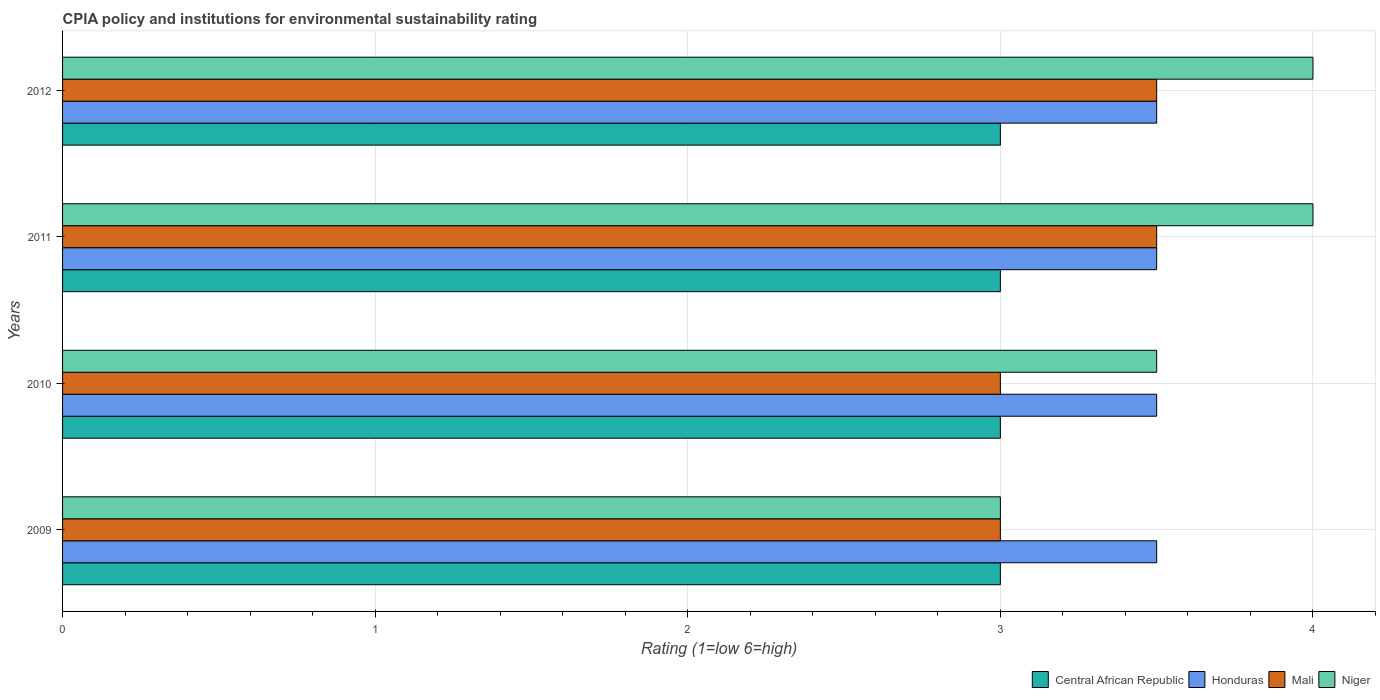How many groups of bars are there?
Make the answer very short. 4. How many bars are there on the 2nd tick from the bottom?
Offer a very short reply. 4. In how many cases, is the number of bars for a given year not equal to the number of legend labels?
Your answer should be compact. 0. What is the CPIA rating in Honduras in 2010?
Offer a very short reply. 3.5. Across all years, what is the maximum CPIA rating in Mali?
Keep it short and to the point. 3.5. Across all years, what is the minimum CPIA rating in Mali?
Your answer should be very brief. 3. In which year was the CPIA rating in Niger maximum?
Your answer should be compact. 2011. What is the difference between the CPIA rating in Central African Republic in 2009 and the CPIA rating in Mali in 2011?
Give a very brief answer. -0.5. What is the average CPIA rating in Honduras per year?
Offer a very short reply. 3.5. In how many years, is the CPIA rating in Niger greater than 0.4 ?
Keep it short and to the point. 4. What is the ratio of the CPIA rating in Honduras in 2009 to that in 2010?
Ensure brevity in your answer.  1. What is the difference between the highest and the second highest CPIA rating in Niger?
Your answer should be very brief. 0. What is the difference between the highest and the lowest CPIA rating in Niger?
Provide a succinct answer. 1. Is it the case that in every year, the sum of the CPIA rating in Central African Republic and CPIA rating in Mali is greater than the sum of CPIA rating in Honduras and CPIA rating in Niger?
Offer a very short reply. No. What does the 4th bar from the top in 2011 represents?
Your answer should be very brief. Central African Republic. What does the 4th bar from the bottom in 2010 represents?
Provide a succinct answer. Niger. Is it the case that in every year, the sum of the CPIA rating in Mali and CPIA rating in Niger is greater than the CPIA rating in Honduras?
Provide a short and direct response. Yes. Are all the bars in the graph horizontal?
Your answer should be compact. Yes. How many years are there in the graph?
Your answer should be very brief. 4. What is the difference between two consecutive major ticks on the X-axis?
Make the answer very short. 1. Does the graph contain any zero values?
Offer a very short reply. No. Does the graph contain grids?
Make the answer very short. Yes. How many legend labels are there?
Offer a terse response. 4. What is the title of the graph?
Offer a very short reply. CPIA policy and institutions for environmental sustainability rating. Does "Guatemala" appear as one of the legend labels in the graph?
Your answer should be compact. No. What is the label or title of the X-axis?
Ensure brevity in your answer.  Rating (1=low 6=high). What is the Rating (1=low 6=high) of Central African Republic in 2009?
Give a very brief answer. 3. What is the Rating (1=low 6=high) in Honduras in 2009?
Your response must be concise. 3.5. What is the Rating (1=low 6=high) in Mali in 2009?
Give a very brief answer. 3. What is the Rating (1=low 6=high) in Niger in 2009?
Provide a short and direct response. 3. What is the Rating (1=low 6=high) in Central African Republic in 2010?
Make the answer very short. 3. What is the Rating (1=low 6=high) of Honduras in 2010?
Give a very brief answer. 3.5. What is the Rating (1=low 6=high) in Mali in 2010?
Offer a terse response. 3. What is the Rating (1=low 6=high) in Niger in 2010?
Give a very brief answer. 3.5. What is the Rating (1=low 6=high) of Central African Republic in 2011?
Offer a very short reply. 3. What is the Rating (1=low 6=high) of Honduras in 2011?
Your answer should be compact. 3.5. What is the Rating (1=low 6=high) in Mali in 2011?
Keep it short and to the point. 3.5. What is the Rating (1=low 6=high) of Niger in 2011?
Provide a succinct answer. 4. What is the Rating (1=low 6=high) in Central African Republic in 2012?
Your answer should be compact. 3. What is the Rating (1=low 6=high) in Mali in 2012?
Give a very brief answer. 3.5. What is the Rating (1=low 6=high) in Niger in 2012?
Offer a very short reply. 4. Across all years, what is the maximum Rating (1=low 6=high) in Central African Republic?
Your response must be concise. 3. Across all years, what is the maximum Rating (1=low 6=high) of Niger?
Ensure brevity in your answer.  4. Across all years, what is the minimum Rating (1=low 6=high) of Mali?
Offer a very short reply. 3. What is the total Rating (1=low 6=high) in Central African Republic in the graph?
Keep it short and to the point. 12. What is the total Rating (1=low 6=high) in Mali in the graph?
Give a very brief answer. 13. What is the total Rating (1=low 6=high) of Niger in the graph?
Make the answer very short. 14.5. What is the difference between the Rating (1=low 6=high) in Honduras in 2009 and that in 2011?
Ensure brevity in your answer.  0. What is the difference between the Rating (1=low 6=high) in Mali in 2009 and that in 2011?
Offer a terse response. -0.5. What is the difference between the Rating (1=low 6=high) in Niger in 2009 and that in 2011?
Offer a very short reply. -1. What is the difference between the Rating (1=low 6=high) of Honduras in 2009 and that in 2012?
Ensure brevity in your answer.  0. What is the difference between the Rating (1=low 6=high) in Mali in 2009 and that in 2012?
Your answer should be very brief. -0.5. What is the difference between the Rating (1=low 6=high) of Central African Republic in 2010 and that in 2011?
Ensure brevity in your answer.  0. What is the difference between the Rating (1=low 6=high) of Niger in 2010 and that in 2011?
Provide a short and direct response. -0.5. What is the difference between the Rating (1=low 6=high) of Central African Republic in 2010 and that in 2012?
Ensure brevity in your answer.  0. What is the difference between the Rating (1=low 6=high) of Mali in 2010 and that in 2012?
Your response must be concise. -0.5. What is the difference between the Rating (1=low 6=high) in Niger in 2010 and that in 2012?
Your answer should be very brief. -0.5. What is the difference between the Rating (1=low 6=high) in Central African Republic in 2009 and the Rating (1=low 6=high) in Mali in 2010?
Provide a succinct answer. 0. What is the difference between the Rating (1=low 6=high) in Central African Republic in 2009 and the Rating (1=low 6=high) in Niger in 2010?
Ensure brevity in your answer.  -0.5. What is the difference between the Rating (1=low 6=high) of Honduras in 2009 and the Rating (1=low 6=high) of Mali in 2010?
Your answer should be compact. 0.5. What is the difference between the Rating (1=low 6=high) of Honduras in 2009 and the Rating (1=low 6=high) of Niger in 2010?
Ensure brevity in your answer.  0. What is the difference between the Rating (1=low 6=high) of Honduras in 2009 and the Rating (1=low 6=high) of Mali in 2011?
Offer a very short reply. 0. What is the difference between the Rating (1=low 6=high) in Central African Republic in 2009 and the Rating (1=low 6=high) in Mali in 2012?
Make the answer very short. -0.5. What is the difference between the Rating (1=low 6=high) in Honduras in 2009 and the Rating (1=low 6=high) in Mali in 2012?
Provide a succinct answer. 0. What is the difference between the Rating (1=low 6=high) in Honduras in 2009 and the Rating (1=low 6=high) in Niger in 2012?
Keep it short and to the point. -0.5. What is the difference between the Rating (1=low 6=high) of Mali in 2009 and the Rating (1=low 6=high) of Niger in 2012?
Offer a very short reply. -1. What is the difference between the Rating (1=low 6=high) of Central African Republic in 2010 and the Rating (1=low 6=high) of Honduras in 2011?
Keep it short and to the point. -0.5. What is the difference between the Rating (1=low 6=high) of Central African Republic in 2010 and the Rating (1=low 6=high) of Niger in 2011?
Your answer should be compact. -1. What is the difference between the Rating (1=low 6=high) in Honduras in 2010 and the Rating (1=low 6=high) in Mali in 2011?
Offer a terse response. 0. What is the difference between the Rating (1=low 6=high) in Mali in 2010 and the Rating (1=low 6=high) in Niger in 2011?
Ensure brevity in your answer.  -1. What is the difference between the Rating (1=low 6=high) in Honduras in 2010 and the Rating (1=low 6=high) in Mali in 2012?
Provide a succinct answer. 0. What is the difference between the Rating (1=low 6=high) in Mali in 2010 and the Rating (1=low 6=high) in Niger in 2012?
Offer a terse response. -1. What is the difference between the Rating (1=low 6=high) of Central African Republic in 2011 and the Rating (1=low 6=high) of Niger in 2012?
Your answer should be very brief. -1. What is the difference between the Rating (1=low 6=high) of Honduras in 2011 and the Rating (1=low 6=high) of Mali in 2012?
Provide a succinct answer. 0. What is the difference between the Rating (1=low 6=high) of Honduras in 2011 and the Rating (1=low 6=high) of Niger in 2012?
Provide a succinct answer. -0.5. What is the average Rating (1=low 6=high) in Honduras per year?
Ensure brevity in your answer.  3.5. What is the average Rating (1=low 6=high) in Niger per year?
Offer a very short reply. 3.62. In the year 2009, what is the difference between the Rating (1=low 6=high) of Central African Republic and Rating (1=low 6=high) of Honduras?
Provide a short and direct response. -0.5. In the year 2009, what is the difference between the Rating (1=low 6=high) of Central African Republic and Rating (1=low 6=high) of Mali?
Your answer should be compact. 0. In the year 2009, what is the difference between the Rating (1=low 6=high) in Honduras and Rating (1=low 6=high) in Mali?
Offer a terse response. 0.5. In the year 2009, what is the difference between the Rating (1=low 6=high) of Mali and Rating (1=low 6=high) of Niger?
Give a very brief answer. 0. In the year 2010, what is the difference between the Rating (1=low 6=high) of Central African Republic and Rating (1=low 6=high) of Niger?
Make the answer very short. -0.5. In the year 2010, what is the difference between the Rating (1=low 6=high) of Honduras and Rating (1=low 6=high) of Mali?
Ensure brevity in your answer.  0.5. In the year 2010, what is the difference between the Rating (1=low 6=high) in Honduras and Rating (1=low 6=high) in Niger?
Provide a succinct answer. 0. In the year 2010, what is the difference between the Rating (1=low 6=high) of Mali and Rating (1=low 6=high) of Niger?
Offer a terse response. -0.5. In the year 2011, what is the difference between the Rating (1=low 6=high) of Central African Republic and Rating (1=low 6=high) of Mali?
Provide a short and direct response. -0.5. In the year 2011, what is the difference between the Rating (1=low 6=high) of Central African Republic and Rating (1=low 6=high) of Niger?
Provide a succinct answer. -1. In the year 2011, what is the difference between the Rating (1=low 6=high) in Honduras and Rating (1=low 6=high) in Mali?
Give a very brief answer. 0. In the year 2011, what is the difference between the Rating (1=low 6=high) of Honduras and Rating (1=low 6=high) of Niger?
Provide a short and direct response. -0.5. In the year 2012, what is the difference between the Rating (1=low 6=high) in Central African Republic and Rating (1=low 6=high) in Niger?
Give a very brief answer. -1. What is the ratio of the Rating (1=low 6=high) in Central African Republic in 2009 to that in 2010?
Your answer should be very brief. 1. What is the ratio of the Rating (1=low 6=high) in Honduras in 2009 to that in 2010?
Your answer should be very brief. 1. What is the ratio of the Rating (1=low 6=high) of Mali in 2009 to that in 2010?
Provide a succinct answer. 1. What is the ratio of the Rating (1=low 6=high) of Central African Republic in 2009 to that in 2011?
Offer a terse response. 1. What is the ratio of the Rating (1=low 6=high) in Niger in 2009 to that in 2011?
Provide a short and direct response. 0.75. What is the ratio of the Rating (1=low 6=high) of Mali in 2009 to that in 2012?
Provide a short and direct response. 0.86. What is the ratio of the Rating (1=low 6=high) of Honduras in 2010 to that in 2011?
Your response must be concise. 1. What is the ratio of the Rating (1=low 6=high) of Mali in 2010 to that in 2011?
Make the answer very short. 0.86. What is the ratio of the Rating (1=low 6=high) of Central African Republic in 2010 to that in 2012?
Your answer should be very brief. 1. What is the ratio of the Rating (1=low 6=high) in Mali in 2010 to that in 2012?
Provide a short and direct response. 0.86. What is the ratio of the Rating (1=low 6=high) of Niger in 2010 to that in 2012?
Your response must be concise. 0.88. What is the ratio of the Rating (1=low 6=high) in Central African Republic in 2011 to that in 2012?
Offer a very short reply. 1. What is the ratio of the Rating (1=low 6=high) of Mali in 2011 to that in 2012?
Your response must be concise. 1. What is the ratio of the Rating (1=low 6=high) of Niger in 2011 to that in 2012?
Your answer should be very brief. 1. What is the difference between the highest and the second highest Rating (1=low 6=high) in Central African Republic?
Offer a terse response. 0. What is the difference between the highest and the second highest Rating (1=low 6=high) of Honduras?
Your answer should be compact. 0. What is the difference between the highest and the second highest Rating (1=low 6=high) in Mali?
Offer a terse response. 0. What is the difference between the highest and the lowest Rating (1=low 6=high) in Central African Republic?
Give a very brief answer. 0. What is the difference between the highest and the lowest Rating (1=low 6=high) in Mali?
Keep it short and to the point. 0.5. 